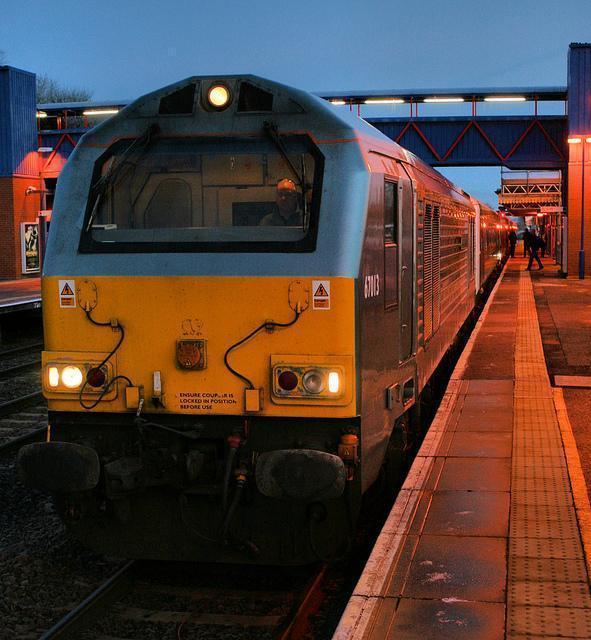What is the man inside the front of the training doing?
Pick the right solution, then justify: 'Answer: answer
Rationale: rationale.'
Options: Driving, loading, boarding, policing. Answer: driving.
Rationale: The man is operating the train. 